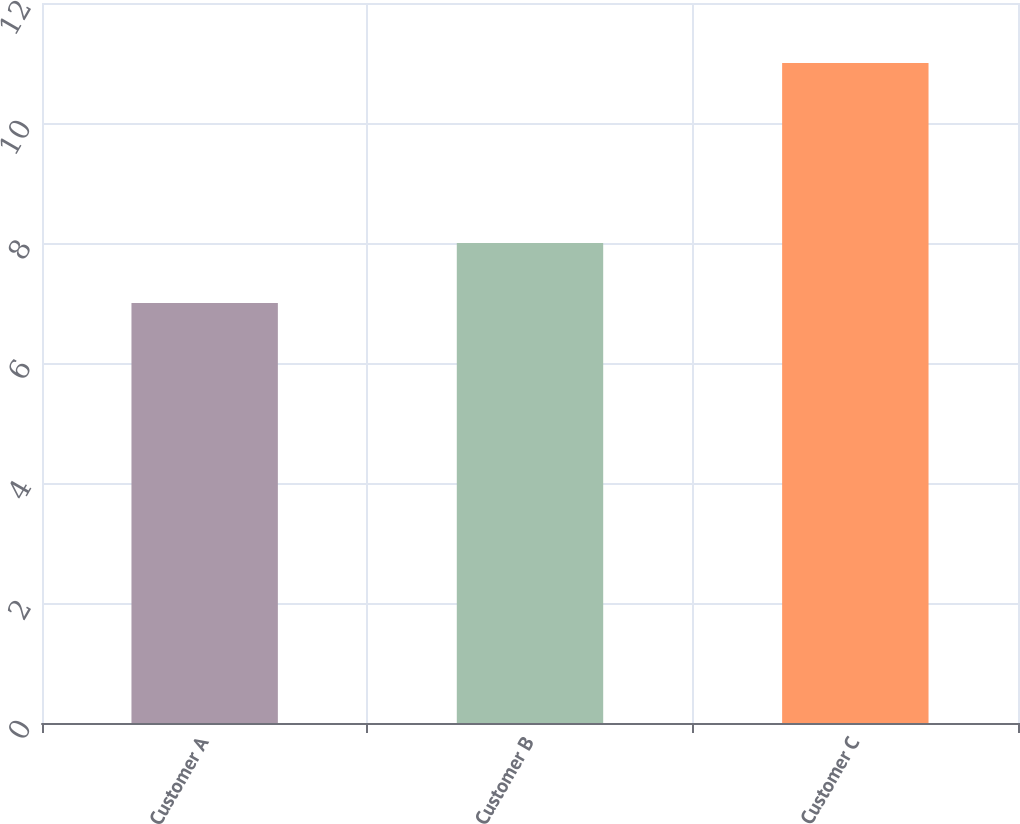Convert chart to OTSL. <chart><loc_0><loc_0><loc_500><loc_500><bar_chart><fcel>Customer A<fcel>Customer B<fcel>Customer C<nl><fcel>7<fcel>8<fcel>11<nl></chart> 